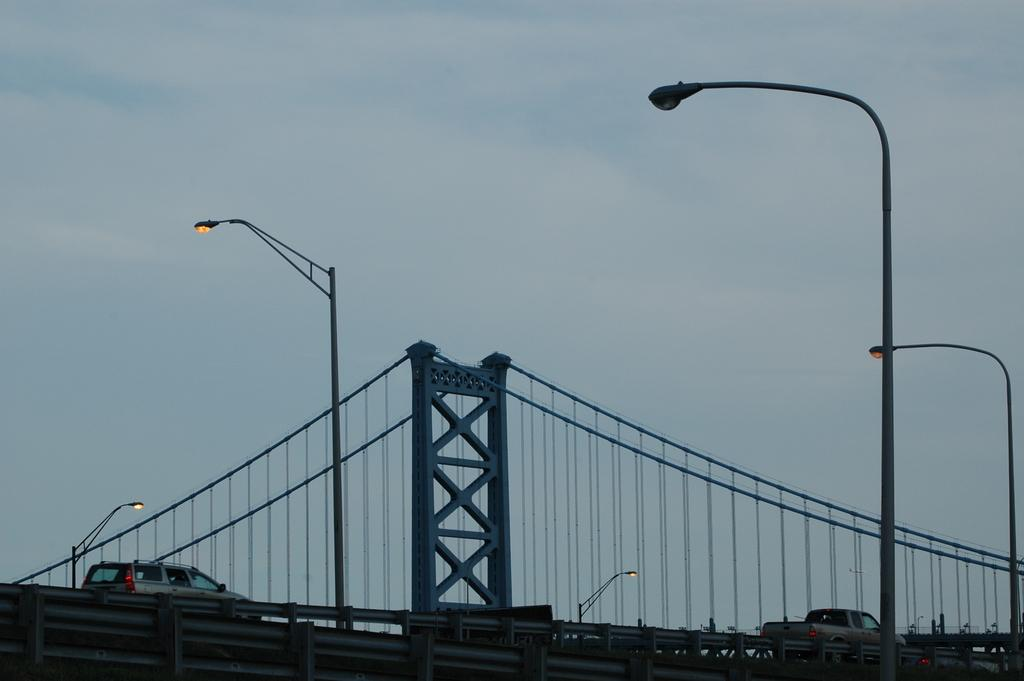What structure is the main focus of the image? There is a bridge in the image. What is happening on the bridge? Cars are moving on the bridge. Are there any additional features on the bridge? Yes, there are lights fixed to poles. What can be seen in the background of the image? The sky is visible in the background of the image. Where is the dock located in the image? There is no dock present in the image. What type of lamp is placed on the rock in the image? There is no lamp or rock present in the image. 